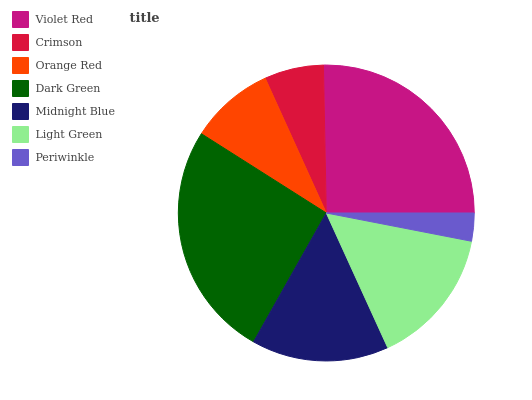Is Periwinkle the minimum?
Answer yes or no. Yes. Is Dark Green the maximum?
Answer yes or no. Yes. Is Crimson the minimum?
Answer yes or no. No. Is Crimson the maximum?
Answer yes or no. No. Is Violet Red greater than Crimson?
Answer yes or no. Yes. Is Crimson less than Violet Red?
Answer yes or no. Yes. Is Crimson greater than Violet Red?
Answer yes or no. No. Is Violet Red less than Crimson?
Answer yes or no. No. Is Midnight Blue the high median?
Answer yes or no. Yes. Is Midnight Blue the low median?
Answer yes or no. Yes. Is Dark Green the high median?
Answer yes or no. No. Is Dark Green the low median?
Answer yes or no. No. 